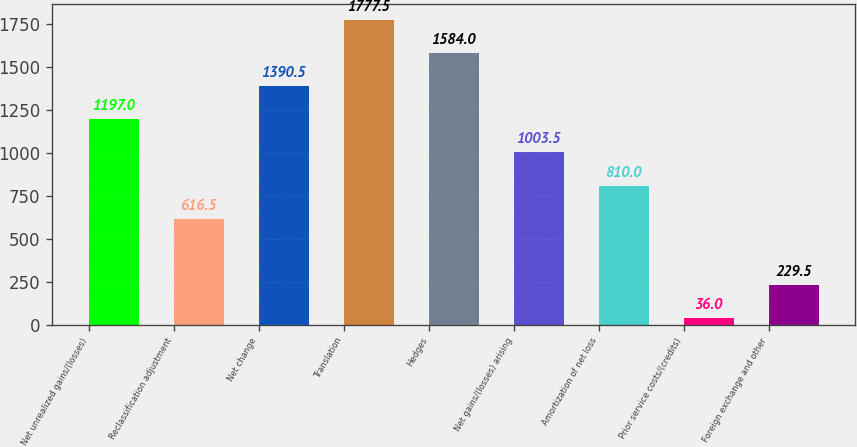Convert chart to OTSL. <chart><loc_0><loc_0><loc_500><loc_500><bar_chart><fcel>Net unrealized gains/(losses)<fcel>Reclassification adjustment<fcel>Net change<fcel>Translation<fcel>Hedges<fcel>Net gains/(losses) arising<fcel>Amortization of net loss<fcel>Prior service costs/(credits)<fcel>Foreign exchange and other<nl><fcel>1197<fcel>616.5<fcel>1390.5<fcel>1777.5<fcel>1584<fcel>1003.5<fcel>810<fcel>36<fcel>229.5<nl></chart> 